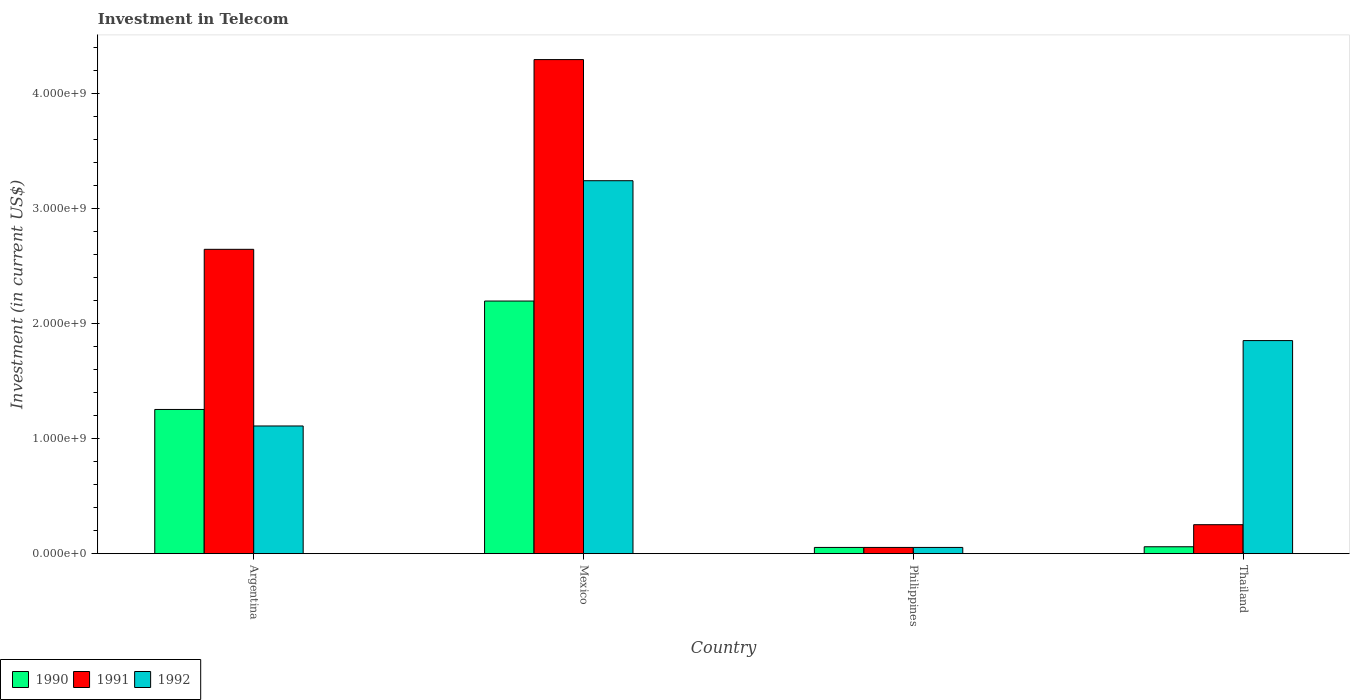How many different coloured bars are there?
Your response must be concise. 3. Are the number of bars per tick equal to the number of legend labels?
Your answer should be very brief. Yes. Are the number of bars on each tick of the X-axis equal?
Your answer should be compact. Yes. How many bars are there on the 4th tick from the left?
Provide a succinct answer. 3. What is the label of the 4th group of bars from the left?
Your response must be concise. Thailand. In how many cases, is the number of bars for a given country not equal to the number of legend labels?
Your answer should be compact. 0. What is the amount invested in telecom in 1991 in Mexico?
Give a very brief answer. 4.30e+09. Across all countries, what is the maximum amount invested in telecom in 1991?
Offer a very short reply. 4.30e+09. Across all countries, what is the minimum amount invested in telecom in 1990?
Your answer should be very brief. 5.42e+07. In which country was the amount invested in telecom in 1991 maximum?
Offer a terse response. Mexico. What is the total amount invested in telecom in 1992 in the graph?
Your answer should be very brief. 6.26e+09. What is the difference between the amount invested in telecom in 1990 in Argentina and that in Thailand?
Make the answer very short. 1.19e+09. What is the difference between the amount invested in telecom in 1992 in Thailand and the amount invested in telecom in 1991 in Philippines?
Provide a short and direct response. 1.80e+09. What is the average amount invested in telecom in 1990 per country?
Provide a succinct answer. 8.92e+08. What is the difference between the amount invested in telecom of/in 1992 and amount invested in telecom of/in 1991 in Mexico?
Give a very brief answer. -1.05e+09. What is the ratio of the amount invested in telecom in 1991 in Mexico to that in Philippines?
Your response must be concise. 79.32. Is the difference between the amount invested in telecom in 1992 in Mexico and Philippines greater than the difference between the amount invested in telecom in 1991 in Mexico and Philippines?
Your answer should be very brief. No. What is the difference between the highest and the second highest amount invested in telecom in 1992?
Keep it short and to the point. 1.39e+09. What is the difference between the highest and the lowest amount invested in telecom in 1991?
Keep it short and to the point. 4.24e+09. Is the sum of the amount invested in telecom in 1991 in Mexico and Thailand greater than the maximum amount invested in telecom in 1990 across all countries?
Give a very brief answer. Yes. How many bars are there?
Offer a very short reply. 12. How many countries are there in the graph?
Your response must be concise. 4. What is the difference between two consecutive major ticks on the Y-axis?
Provide a short and direct response. 1.00e+09. Are the values on the major ticks of Y-axis written in scientific E-notation?
Keep it short and to the point. Yes. Does the graph contain any zero values?
Provide a succinct answer. No. Where does the legend appear in the graph?
Offer a terse response. Bottom left. What is the title of the graph?
Make the answer very short. Investment in Telecom. Does "1988" appear as one of the legend labels in the graph?
Your response must be concise. No. What is the label or title of the X-axis?
Keep it short and to the point. Country. What is the label or title of the Y-axis?
Provide a short and direct response. Investment (in current US$). What is the Investment (in current US$) of 1990 in Argentina?
Give a very brief answer. 1.25e+09. What is the Investment (in current US$) of 1991 in Argentina?
Keep it short and to the point. 2.65e+09. What is the Investment (in current US$) in 1992 in Argentina?
Give a very brief answer. 1.11e+09. What is the Investment (in current US$) of 1990 in Mexico?
Offer a terse response. 2.20e+09. What is the Investment (in current US$) in 1991 in Mexico?
Provide a short and direct response. 4.30e+09. What is the Investment (in current US$) in 1992 in Mexico?
Provide a succinct answer. 3.24e+09. What is the Investment (in current US$) in 1990 in Philippines?
Your response must be concise. 5.42e+07. What is the Investment (in current US$) in 1991 in Philippines?
Keep it short and to the point. 5.42e+07. What is the Investment (in current US$) of 1992 in Philippines?
Your answer should be very brief. 5.42e+07. What is the Investment (in current US$) of 1990 in Thailand?
Your answer should be very brief. 6.00e+07. What is the Investment (in current US$) of 1991 in Thailand?
Keep it short and to the point. 2.52e+08. What is the Investment (in current US$) in 1992 in Thailand?
Offer a very short reply. 1.85e+09. Across all countries, what is the maximum Investment (in current US$) in 1990?
Your answer should be compact. 2.20e+09. Across all countries, what is the maximum Investment (in current US$) in 1991?
Offer a very short reply. 4.30e+09. Across all countries, what is the maximum Investment (in current US$) in 1992?
Provide a succinct answer. 3.24e+09. Across all countries, what is the minimum Investment (in current US$) of 1990?
Provide a succinct answer. 5.42e+07. Across all countries, what is the minimum Investment (in current US$) in 1991?
Offer a very short reply. 5.42e+07. Across all countries, what is the minimum Investment (in current US$) of 1992?
Keep it short and to the point. 5.42e+07. What is the total Investment (in current US$) in 1990 in the graph?
Make the answer very short. 3.57e+09. What is the total Investment (in current US$) of 1991 in the graph?
Offer a terse response. 7.25e+09. What is the total Investment (in current US$) of 1992 in the graph?
Your response must be concise. 6.26e+09. What is the difference between the Investment (in current US$) of 1990 in Argentina and that in Mexico?
Offer a terse response. -9.43e+08. What is the difference between the Investment (in current US$) of 1991 in Argentina and that in Mexico?
Provide a succinct answer. -1.65e+09. What is the difference between the Investment (in current US$) of 1992 in Argentina and that in Mexico?
Offer a very short reply. -2.13e+09. What is the difference between the Investment (in current US$) in 1990 in Argentina and that in Philippines?
Your answer should be compact. 1.20e+09. What is the difference between the Investment (in current US$) of 1991 in Argentina and that in Philippines?
Provide a short and direct response. 2.59e+09. What is the difference between the Investment (in current US$) in 1992 in Argentina and that in Philippines?
Keep it short and to the point. 1.06e+09. What is the difference between the Investment (in current US$) of 1990 in Argentina and that in Thailand?
Keep it short and to the point. 1.19e+09. What is the difference between the Investment (in current US$) of 1991 in Argentina and that in Thailand?
Provide a succinct answer. 2.40e+09. What is the difference between the Investment (in current US$) of 1992 in Argentina and that in Thailand?
Offer a very short reply. -7.43e+08. What is the difference between the Investment (in current US$) of 1990 in Mexico and that in Philippines?
Keep it short and to the point. 2.14e+09. What is the difference between the Investment (in current US$) in 1991 in Mexico and that in Philippines?
Offer a terse response. 4.24e+09. What is the difference between the Investment (in current US$) in 1992 in Mexico and that in Philippines?
Your response must be concise. 3.19e+09. What is the difference between the Investment (in current US$) in 1990 in Mexico and that in Thailand?
Keep it short and to the point. 2.14e+09. What is the difference between the Investment (in current US$) of 1991 in Mexico and that in Thailand?
Keep it short and to the point. 4.05e+09. What is the difference between the Investment (in current US$) in 1992 in Mexico and that in Thailand?
Ensure brevity in your answer.  1.39e+09. What is the difference between the Investment (in current US$) in 1990 in Philippines and that in Thailand?
Provide a short and direct response. -5.80e+06. What is the difference between the Investment (in current US$) of 1991 in Philippines and that in Thailand?
Keep it short and to the point. -1.98e+08. What is the difference between the Investment (in current US$) of 1992 in Philippines and that in Thailand?
Provide a succinct answer. -1.80e+09. What is the difference between the Investment (in current US$) in 1990 in Argentina and the Investment (in current US$) in 1991 in Mexico?
Keep it short and to the point. -3.04e+09. What is the difference between the Investment (in current US$) of 1990 in Argentina and the Investment (in current US$) of 1992 in Mexico?
Your answer should be compact. -1.99e+09. What is the difference between the Investment (in current US$) in 1991 in Argentina and the Investment (in current US$) in 1992 in Mexico?
Your answer should be compact. -5.97e+08. What is the difference between the Investment (in current US$) in 1990 in Argentina and the Investment (in current US$) in 1991 in Philippines?
Your answer should be very brief. 1.20e+09. What is the difference between the Investment (in current US$) in 1990 in Argentina and the Investment (in current US$) in 1992 in Philippines?
Your answer should be very brief. 1.20e+09. What is the difference between the Investment (in current US$) of 1991 in Argentina and the Investment (in current US$) of 1992 in Philippines?
Offer a terse response. 2.59e+09. What is the difference between the Investment (in current US$) in 1990 in Argentina and the Investment (in current US$) in 1991 in Thailand?
Offer a terse response. 1.00e+09. What is the difference between the Investment (in current US$) of 1990 in Argentina and the Investment (in current US$) of 1992 in Thailand?
Provide a short and direct response. -5.99e+08. What is the difference between the Investment (in current US$) in 1991 in Argentina and the Investment (in current US$) in 1992 in Thailand?
Your answer should be compact. 7.94e+08. What is the difference between the Investment (in current US$) in 1990 in Mexico and the Investment (in current US$) in 1991 in Philippines?
Offer a terse response. 2.14e+09. What is the difference between the Investment (in current US$) in 1990 in Mexico and the Investment (in current US$) in 1992 in Philippines?
Ensure brevity in your answer.  2.14e+09. What is the difference between the Investment (in current US$) of 1991 in Mexico and the Investment (in current US$) of 1992 in Philippines?
Make the answer very short. 4.24e+09. What is the difference between the Investment (in current US$) of 1990 in Mexico and the Investment (in current US$) of 1991 in Thailand?
Provide a succinct answer. 1.95e+09. What is the difference between the Investment (in current US$) in 1990 in Mexico and the Investment (in current US$) in 1992 in Thailand?
Offer a very short reply. 3.44e+08. What is the difference between the Investment (in current US$) of 1991 in Mexico and the Investment (in current US$) of 1992 in Thailand?
Keep it short and to the point. 2.44e+09. What is the difference between the Investment (in current US$) of 1990 in Philippines and the Investment (in current US$) of 1991 in Thailand?
Your answer should be compact. -1.98e+08. What is the difference between the Investment (in current US$) in 1990 in Philippines and the Investment (in current US$) in 1992 in Thailand?
Your answer should be very brief. -1.80e+09. What is the difference between the Investment (in current US$) in 1991 in Philippines and the Investment (in current US$) in 1992 in Thailand?
Your answer should be very brief. -1.80e+09. What is the average Investment (in current US$) of 1990 per country?
Offer a terse response. 8.92e+08. What is the average Investment (in current US$) of 1991 per country?
Offer a very short reply. 1.81e+09. What is the average Investment (in current US$) in 1992 per country?
Your answer should be compact. 1.57e+09. What is the difference between the Investment (in current US$) in 1990 and Investment (in current US$) in 1991 in Argentina?
Keep it short and to the point. -1.39e+09. What is the difference between the Investment (in current US$) in 1990 and Investment (in current US$) in 1992 in Argentina?
Offer a terse response. 1.44e+08. What is the difference between the Investment (in current US$) in 1991 and Investment (in current US$) in 1992 in Argentina?
Offer a very short reply. 1.54e+09. What is the difference between the Investment (in current US$) in 1990 and Investment (in current US$) in 1991 in Mexico?
Ensure brevity in your answer.  -2.10e+09. What is the difference between the Investment (in current US$) of 1990 and Investment (in current US$) of 1992 in Mexico?
Your answer should be compact. -1.05e+09. What is the difference between the Investment (in current US$) of 1991 and Investment (in current US$) of 1992 in Mexico?
Your response must be concise. 1.05e+09. What is the difference between the Investment (in current US$) in 1990 and Investment (in current US$) in 1991 in Thailand?
Offer a terse response. -1.92e+08. What is the difference between the Investment (in current US$) of 1990 and Investment (in current US$) of 1992 in Thailand?
Your response must be concise. -1.79e+09. What is the difference between the Investment (in current US$) in 1991 and Investment (in current US$) in 1992 in Thailand?
Provide a succinct answer. -1.60e+09. What is the ratio of the Investment (in current US$) of 1990 in Argentina to that in Mexico?
Give a very brief answer. 0.57. What is the ratio of the Investment (in current US$) of 1991 in Argentina to that in Mexico?
Offer a very short reply. 0.62. What is the ratio of the Investment (in current US$) in 1992 in Argentina to that in Mexico?
Provide a succinct answer. 0.34. What is the ratio of the Investment (in current US$) in 1990 in Argentina to that in Philippines?
Make the answer very short. 23.15. What is the ratio of the Investment (in current US$) of 1991 in Argentina to that in Philippines?
Offer a terse response. 48.86. What is the ratio of the Investment (in current US$) in 1992 in Argentina to that in Philippines?
Your answer should be very brief. 20.5. What is the ratio of the Investment (in current US$) in 1990 in Argentina to that in Thailand?
Your answer should be very brief. 20.91. What is the ratio of the Investment (in current US$) in 1991 in Argentina to that in Thailand?
Your answer should be compact. 10.51. What is the ratio of the Investment (in current US$) in 1992 in Argentina to that in Thailand?
Give a very brief answer. 0.6. What is the ratio of the Investment (in current US$) in 1990 in Mexico to that in Philippines?
Provide a short and direct response. 40.55. What is the ratio of the Investment (in current US$) in 1991 in Mexico to that in Philippines?
Ensure brevity in your answer.  79.32. What is the ratio of the Investment (in current US$) in 1992 in Mexico to that in Philippines?
Offer a terse response. 59.87. What is the ratio of the Investment (in current US$) in 1990 in Mexico to that in Thailand?
Offer a terse response. 36.63. What is the ratio of the Investment (in current US$) in 1991 in Mexico to that in Thailand?
Ensure brevity in your answer.  17.06. What is the ratio of the Investment (in current US$) in 1992 in Mexico to that in Thailand?
Make the answer very short. 1.75. What is the ratio of the Investment (in current US$) of 1990 in Philippines to that in Thailand?
Provide a short and direct response. 0.9. What is the ratio of the Investment (in current US$) in 1991 in Philippines to that in Thailand?
Keep it short and to the point. 0.22. What is the ratio of the Investment (in current US$) in 1992 in Philippines to that in Thailand?
Provide a succinct answer. 0.03. What is the difference between the highest and the second highest Investment (in current US$) of 1990?
Provide a short and direct response. 9.43e+08. What is the difference between the highest and the second highest Investment (in current US$) in 1991?
Keep it short and to the point. 1.65e+09. What is the difference between the highest and the second highest Investment (in current US$) in 1992?
Ensure brevity in your answer.  1.39e+09. What is the difference between the highest and the lowest Investment (in current US$) of 1990?
Give a very brief answer. 2.14e+09. What is the difference between the highest and the lowest Investment (in current US$) in 1991?
Provide a short and direct response. 4.24e+09. What is the difference between the highest and the lowest Investment (in current US$) of 1992?
Give a very brief answer. 3.19e+09. 